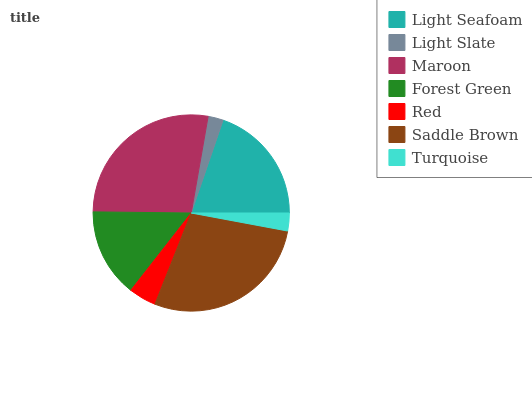Is Light Slate the minimum?
Answer yes or no. Yes. Is Saddle Brown the maximum?
Answer yes or no. Yes. Is Maroon the minimum?
Answer yes or no. No. Is Maroon the maximum?
Answer yes or no. No. Is Maroon greater than Light Slate?
Answer yes or no. Yes. Is Light Slate less than Maroon?
Answer yes or no. Yes. Is Light Slate greater than Maroon?
Answer yes or no. No. Is Maroon less than Light Slate?
Answer yes or no. No. Is Forest Green the high median?
Answer yes or no. Yes. Is Forest Green the low median?
Answer yes or no. Yes. Is Turquoise the high median?
Answer yes or no. No. Is Light Slate the low median?
Answer yes or no. No. 